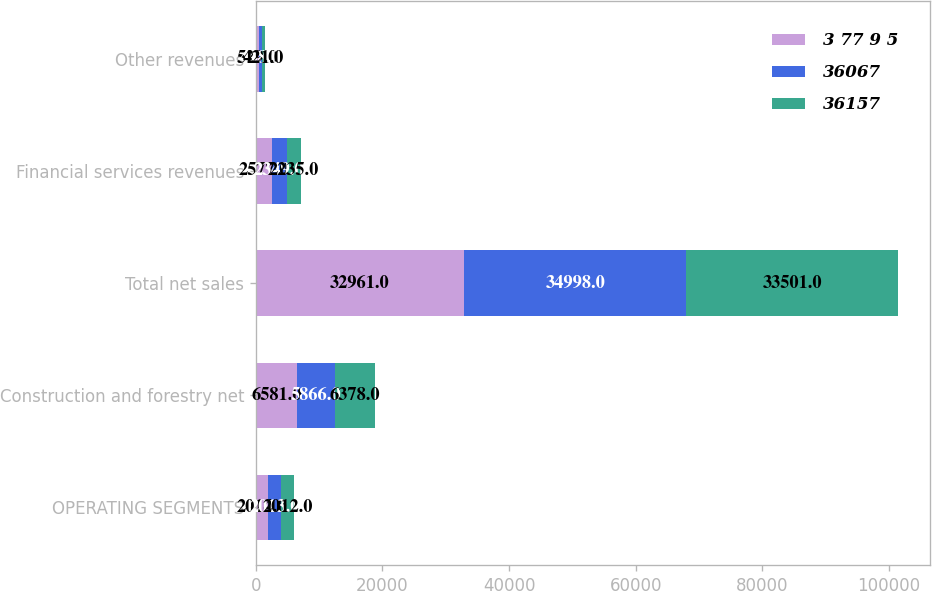Convert chart to OTSL. <chart><loc_0><loc_0><loc_500><loc_500><stacked_bar_chart><ecel><fcel>OPERATING SEGMENTS<fcel>Construction and forestry net<fcel>Total net sales<fcel>Financial services revenues<fcel>Other revenues<nl><fcel>3 77 9 5<fcel>2014<fcel>6581<fcel>32961<fcel>2577<fcel>529<nl><fcel>36067<fcel>2013<fcel>5866<fcel>34998<fcel>2349<fcel>448<nl><fcel>36157<fcel>2012<fcel>6378<fcel>33501<fcel>2235<fcel>421<nl></chart> 